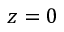Convert formula to latex. <formula><loc_0><loc_0><loc_500><loc_500>z = 0</formula> 